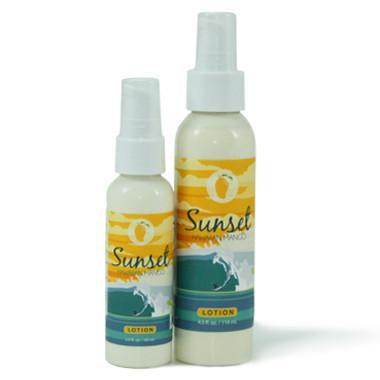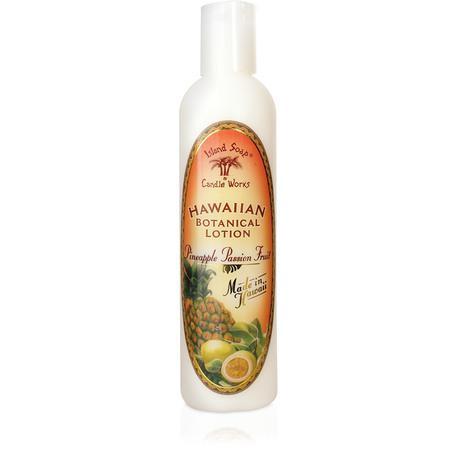The first image is the image on the left, the second image is the image on the right. Examine the images to the left and right. Is the description "An image shows one tube-type skincare product standing upright on its green cap." accurate? Answer yes or no. No. The first image is the image on the left, the second image is the image on the right. Assess this claim about the two images: "There is a single bottle in one of the images, and in the other image there are more than three other bottles.". Correct or not? Answer yes or no. No. 